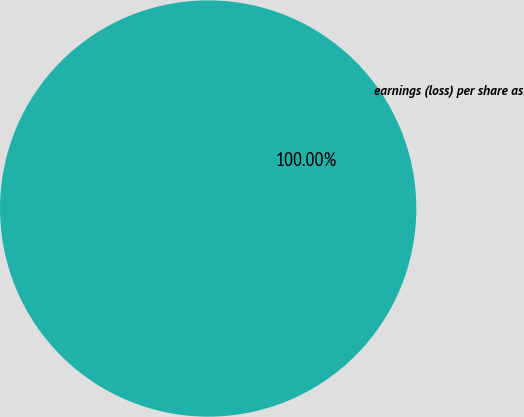Convert chart. <chart><loc_0><loc_0><loc_500><loc_500><pie_chart><fcel>earnings (loss) per share as<nl><fcel>100.0%<nl></chart> 